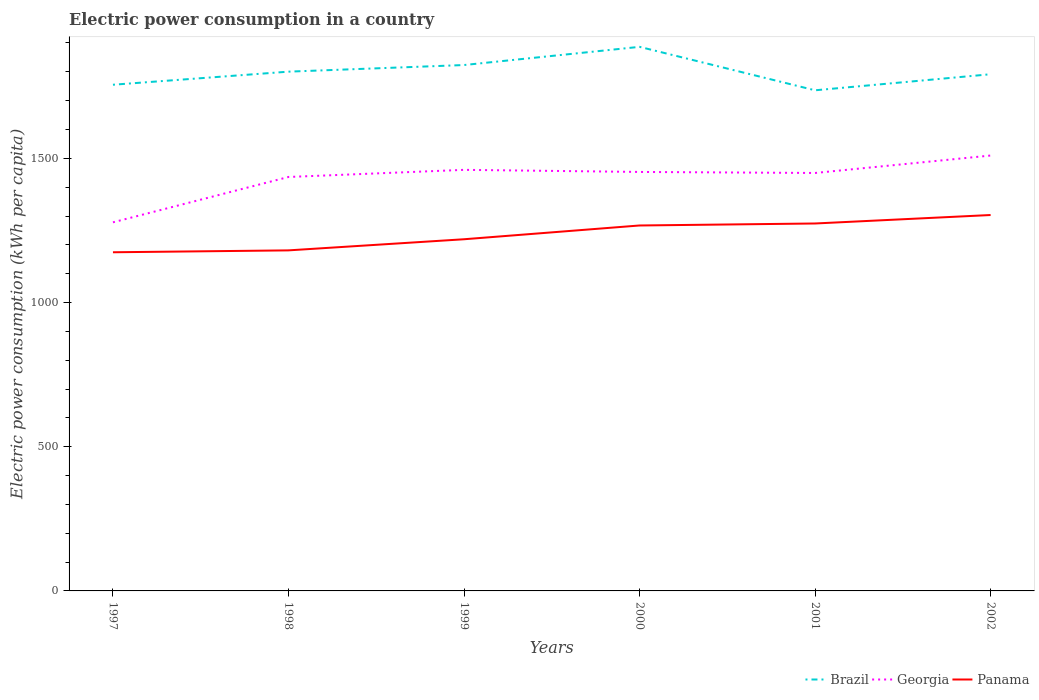How many different coloured lines are there?
Ensure brevity in your answer.  3. Does the line corresponding to Georgia intersect with the line corresponding to Brazil?
Your answer should be compact. No. Across all years, what is the maximum electric power consumption in in Georgia?
Provide a short and direct response. 1278.14. What is the total electric power consumption in in Brazil in the graph?
Give a very brief answer. 19.27. What is the difference between the highest and the second highest electric power consumption in in Georgia?
Provide a short and direct response. 231.62. How many lines are there?
Your response must be concise. 3. How many years are there in the graph?
Offer a terse response. 6. Are the values on the major ticks of Y-axis written in scientific E-notation?
Your response must be concise. No. Does the graph contain any zero values?
Ensure brevity in your answer.  No. Does the graph contain grids?
Ensure brevity in your answer.  No. Where does the legend appear in the graph?
Give a very brief answer. Bottom right. How many legend labels are there?
Offer a terse response. 3. How are the legend labels stacked?
Offer a very short reply. Horizontal. What is the title of the graph?
Ensure brevity in your answer.  Electric power consumption in a country. Does "Switzerland" appear as one of the legend labels in the graph?
Keep it short and to the point. No. What is the label or title of the X-axis?
Ensure brevity in your answer.  Years. What is the label or title of the Y-axis?
Your answer should be compact. Electric power consumption (kWh per capita). What is the Electric power consumption (kWh per capita) of Brazil in 1997?
Keep it short and to the point. 1755.22. What is the Electric power consumption (kWh per capita) of Georgia in 1997?
Your answer should be very brief. 1278.14. What is the Electric power consumption (kWh per capita) of Panama in 1997?
Your answer should be compact. 1174.31. What is the Electric power consumption (kWh per capita) of Brazil in 1998?
Provide a succinct answer. 1800.59. What is the Electric power consumption (kWh per capita) of Georgia in 1998?
Your response must be concise. 1435.38. What is the Electric power consumption (kWh per capita) of Panama in 1998?
Ensure brevity in your answer.  1180.88. What is the Electric power consumption (kWh per capita) of Brazil in 1999?
Offer a very short reply. 1823.55. What is the Electric power consumption (kWh per capita) of Georgia in 1999?
Make the answer very short. 1460.08. What is the Electric power consumption (kWh per capita) of Panama in 1999?
Offer a terse response. 1219.45. What is the Electric power consumption (kWh per capita) of Brazil in 2000?
Offer a terse response. 1886.6. What is the Electric power consumption (kWh per capita) in Georgia in 2000?
Offer a very short reply. 1452.82. What is the Electric power consumption (kWh per capita) in Panama in 2000?
Give a very brief answer. 1267.19. What is the Electric power consumption (kWh per capita) of Brazil in 2001?
Your response must be concise. 1735.95. What is the Electric power consumption (kWh per capita) in Georgia in 2001?
Provide a succinct answer. 1449.25. What is the Electric power consumption (kWh per capita) in Panama in 2001?
Provide a short and direct response. 1274.1. What is the Electric power consumption (kWh per capita) in Brazil in 2002?
Offer a very short reply. 1791.62. What is the Electric power consumption (kWh per capita) of Georgia in 2002?
Provide a succinct answer. 1509.75. What is the Electric power consumption (kWh per capita) of Panama in 2002?
Give a very brief answer. 1303.45. Across all years, what is the maximum Electric power consumption (kWh per capita) of Brazil?
Your answer should be compact. 1886.6. Across all years, what is the maximum Electric power consumption (kWh per capita) of Georgia?
Offer a very short reply. 1509.75. Across all years, what is the maximum Electric power consumption (kWh per capita) in Panama?
Provide a short and direct response. 1303.45. Across all years, what is the minimum Electric power consumption (kWh per capita) in Brazil?
Ensure brevity in your answer.  1735.95. Across all years, what is the minimum Electric power consumption (kWh per capita) in Georgia?
Your answer should be compact. 1278.14. Across all years, what is the minimum Electric power consumption (kWh per capita) of Panama?
Your answer should be very brief. 1174.31. What is the total Electric power consumption (kWh per capita) in Brazil in the graph?
Ensure brevity in your answer.  1.08e+04. What is the total Electric power consumption (kWh per capita) in Georgia in the graph?
Your answer should be compact. 8585.43. What is the total Electric power consumption (kWh per capita) of Panama in the graph?
Your response must be concise. 7419.38. What is the difference between the Electric power consumption (kWh per capita) in Brazil in 1997 and that in 1998?
Offer a terse response. -45.37. What is the difference between the Electric power consumption (kWh per capita) of Georgia in 1997 and that in 1998?
Give a very brief answer. -157.25. What is the difference between the Electric power consumption (kWh per capita) of Panama in 1997 and that in 1998?
Keep it short and to the point. -6.57. What is the difference between the Electric power consumption (kWh per capita) in Brazil in 1997 and that in 1999?
Provide a succinct answer. -68.33. What is the difference between the Electric power consumption (kWh per capita) in Georgia in 1997 and that in 1999?
Give a very brief answer. -181.94. What is the difference between the Electric power consumption (kWh per capita) in Panama in 1997 and that in 1999?
Provide a short and direct response. -45.14. What is the difference between the Electric power consumption (kWh per capita) of Brazil in 1997 and that in 2000?
Make the answer very short. -131.38. What is the difference between the Electric power consumption (kWh per capita) of Georgia in 1997 and that in 2000?
Make the answer very short. -174.69. What is the difference between the Electric power consumption (kWh per capita) of Panama in 1997 and that in 2000?
Your answer should be compact. -92.88. What is the difference between the Electric power consumption (kWh per capita) of Brazil in 1997 and that in 2001?
Make the answer very short. 19.27. What is the difference between the Electric power consumption (kWh per capita) of Georgia in 1997 and that in 2001?
Offer a terse response. -171.12. What is the difference between the Electric power consumption (kWh per capita) in Panama in 1997 and that in 2001?
Offer a terse response. -99.79. What is the difference between the Electric power consumption (kWh per capita) of Brazil in 1997 and that in 2002?
Offer a terse response. -36.4. What is the difference between the Electric power consumption (kWh per capita) in Georgia in 1997 and that in 2002?
Offer a very short reply. -231.62. What is the difference between the Electric power consumption (kWh per capita) in Panama in 1997 and that in 2002?
Offer a terse response. -129.14. What is the difference between the Electric power consumption (kWh per capita) of Brazil in 1998 and that in 1999?
Make the answer very short. -22.96. What is the difference between the Electric power consumption (kWh per capita) of Georgia in 1998 and that in 1999?
Offer a very short reply. -24.69. What is the difference between the Electric power consumption (kWh per capita) of Panama in 1998 and that in 1999?
Offer a terse response. -38.57. What is the difference between the Electric power consumption (kWh per capita) of Brazil in 1998 and that in 2000?
Provide a short and direct response. -86.01. What is the difference between the Electric power consumption (kWh per capita) in Georgia in 1998 and that in 2000?
Keep it short and to the point. -17.44. What is the difference between the Electric power consumption (kWh per capita) in Panama in 1998 and that in 2000?
Offer a very short reply. -86.31. What is the difference between the Electric power consumption (kWh per capita) in Brazil in 1998 and that in 2001?
Offer a very short reply. 64.63. What is the difference between the Electric power consumption (kWh per capita) in Georgia in 1998 and that in 2001?
Offer a very short reply. -13.87. What is the difference between the Electric power consumption (kWh per capita) in Panama in 1998 and that in 2001?
Provide a succinct answer. -93.22. What is the difference between the Electric power consumption (kWh per capita) of Brazil in 1998 and that in 2002?
Your answer should be very brief. 8.97. What is the difference between the Electric power consumption (kWh per capita) in Georgia in 1998 and that in 2002?
Give a very brief answer. -74.37. What is the difference between the Electric power consumption (kWh per capita) of Panama in 1998 and that in 2002?
Give a very brief answer. -122.57. What is the difference between the Electric power consumption (kWh per capita) in Brazil in 1999 and that in 2000?
Ensure brevity in your answer.  -63.05. What is the difference between the Electric power consumption (kWh per capita) in Georgia in 1999 and that in 2000?
Offer a terse response. 7.26. What is the difference between the Electric power consumption (kWh per capita) in Panama in 1999 and that in 2000?
Offer a very short reply. -47.74. What is the difference between the Electric power consumption (kWh per capita) in Brazil in 1999 and that in 2001?
Make the answer very short. 87.59. What is the difference between the Electric power consumption (kWh per capita) of Georgia in 1999 and that in 2001?
Offer a terse response. 10.83. What is the difference between the Electric power consumption (kWh per capita) of Panama in 1999 and that in 2001?
Ensure brevity in your answer.  -54.65. What is the difference between the Electric power consumption (kWh per capita) in Brazil in 1999 and that in 2002?
Your response must be concise. 31.93. What is the difference between the Electric power consumption (kWh per capita) of Georgia in 1999 and that in 2002?
Keep it short and to the point. -49.68. What is the difference between the Electric power consumption (kWh per capita) of Panama in 1999 and that in 2002?
Your answer should be very brief. -84. What is the difference between the Electric power consumption (kWh per capita) in Brazil in 2000 and that in 2001?
Your response must be concise. 150.65. What is the difference between the Electric power consumption (kWh per capita) of Georgia in 2000 and that in 2001?
Your response must be concise. 3.57. What is the difference between the Electric power consumption (kWh per capita) in Panama in 2000 and that in 2001?
Your response must be concise. -6.91. What is the difference between the Electric power consumption (kWh per capita) in Brazil in 2000 and that in 2002?
Your response must be concise. 94.98. What is the difference between the Electric power consumption (kWh per capita) in Georgia in 2000 and that in 2002?
Provide a short and direct response. -56.93. What is the difference between the Electric power consumption (kWh per capita) in Panama in 2000 and that in 2002?
Keep it short and to the point. -36.26. What is the difference between the Electric power consumption (kWh per capita) of Brazil in 2001 and that in 2002?
Make the answer very short. -55.67. What is the difference between the Electric power consumption (kWh per capita) in Georgia in 2001 and that in 2002?
Provide a succinct answer. -60.5. What is the difference between the Electric power consumption (kWh per capita) in Panama in 2001 and that in 2002?
Your answer should be compact. -29.35. What is the difference between the Electric power consumption (kWh per capita) in Brazil in 1997 and the Electric power consumption (kWh per capita) in Georgia in 1998?
Keep it short and to the point. 319.84. What is the difference between the Electric power consumption (kWh per capita) in Brazil in 1997 and the Electric power consumption (kWh per capita) in Panama in 1998?
Your response must be concise. 574.34. What is the difference between the Electric power consumption (kWh per capita) in Georgia in 1997 and the Electric power consumption (kWh per capita) in Panama in 1998?
Give a very brief answer. 97.25. What is the difference between the Electric power consumption (kWh per capita) in Brazil in 1997 and the Electric power consumption (kWh per capita) in Georgia in 1999?
Your answer should be compact. 295.14. What is the difference between the Electric power consumption (kWh per capita) in Brazil in 1997 and the Electric power consumption (kWh per capita) in Panama in 1999?
Ensure brevity in your answer.  535.77. What is the difference between the Electric power consumption (kWh per capita) of Georgia in 1997 and the Electric power consumption (kWh per capita) of Panama in 1999?
Keep it short and to the point. 58.69. What is the difference between the Electric power consumption (kWh per capita) in Brazil in 1997 and the Electric power consumption (kWh per capita) in Georgia in 2000?
Ensure brevity in your answer.  302.4. What is the difference between the Electric power consumption (kWh per capita) in Brazil in 1997 and the Electric power consumption (kWh per capita) in Panama in 2000?
Offer a terse response. 488.03. What is the difference between the Electric power consumption (kWh per capita) in Georgia in 1997 and the Electric power consumption (kWh per capita) in Panama in 2000?
Offer a very short reply. 10.95. What is the difference between the Electric power consumption (kWh per capita) of Brazil in 1997 and the Electric power consumption (kWh per capita) of Georgia in 2001?
Make the answer very short. 305.97. What is the difference between the Electric power consumption (kWh per capita) of Brazil in 1997 and the Electric power consumption (kWh per capita) of Panama in 2001?
Your response must be concise. 481.12. What is the difference between the Electric power consumption (kWh per capita) in Georgia in 1997 and the Electric power consumption (kWh per capita) in Panama in 2001?
Give a very brief answer. 4.04. What is the difference between the Electric power consumption (kWh per capita) of Brazil in 1997 and the Electric power consumption (kWh per capita) of Georgia in 2002?
Offer a terse response. 245.47. What is the difference between the Electric power consumption (kWh per capita) in Brazil in 1997 and the Electric power consumption (kWh per capita) in Panama in 2002?
Provide a short and direct response. 451.77. What is the difference between the Electric power consumption (kWh per capita) in Georgia in 1997 and the Electric power consumption (kWh per capita) in Panama in 2002?
Offer a terse response. -25.32. What is the difference between the Electric power consumption (kWh per capita) of Brazil in 1998 and the Electric power consumption (kWh per capita) of Georgia in 1999?
Make the answer very short. 340.51. What is the difference between the Electric power consumption (kWh per capita) of Brazil in 1998 and the Electric power consumption (kWh per capita) of Panama in 1999?
Give a very brief answer. 581.14. What is the difference between the Electric power consumption (kWh per capita) of Georgia in 1998 and the Electric power consumption (kWh per capita) of Panama in 1999?
Ensure brevity in your answer.  215.93. What is the difference between the Electric power consumption (kWh per capita) in Brazil in 1998 and the Electric power consumption (kWh per capita) in Georgia in 2000?
Offer a very short reply. 347.77. What is the difference between the Electric power consumption (kWh per capita) in Brazil in 1998 and the Electric power consumption (kWh per capita) in Panama in 2000?
Offer a terse response. 533.4. What is the difference between the Electric power consumption (kWh per capita) of Georgia in 1998 and the Electric power consumption (kWh per capita) of Panama in 2000?
Provide a succinct answer. 168.2. What is the difference between the Electric power consumption (kWh per capita) of Brazil in 1998 and the Electric power consumption (kWh per capita) of Georgia in 2001?
Make the answer very short. 351.34. What is the difference between the Electric power consumption (kWh per capita) of Brazil in 1998 and the Electric power consumption (kWh per capita) of Panama in 2001?
Offer a very short reply. 526.49. What is the difference between the Electric power consumption (kWh per capita) of Georgia in 1998 and the Electric power consumption (kWh per capita) of Panama in 2001?
Offer a terse response. 161.29. What is the difference between the Electric power consumption (kWh per capita) of Brazil in 1998 and the Electric power consumption (kWh per capita) of Georgia in 2002?
Your answer should be very brief. 290.83. What is the difference between the Electric power consumption (kWh per capita) of Brazil in 1998 and the Electric power consumption (kWh per capita) of Panama in 2002?
Give a very brief answer. 497.14. What is the difference between the Electric power consumption (kWh per capita) in Georgia in 1998 and the Electric power consumption (kWh per capita) in Panama in 2002?
Your answer should be compact. 131.93. What is the difference between the Electric power consumption (kWh per capita) of Brazil in 1999 and the Electric power consumption (kWh per capita) of Georgia in 2000?
Make the answer very short. 370.73. What is the difference between the Electric power consumption (kWh per capita) in Brazil in 1999 and the Electric power consumption (kWh per capita) in Panama in 2000?
Make the answer very short. 556.36. What is the difference between the Electric power consumption (kWh per capita) in Georgia in 1999 and the Electric power consumption (kWh per capita) in Panama in 2000?
Your answer should be very brief. 192.89. What is the difference between the Electric power consumption (kWh per capita) of Brazil in 1999 and the Electric power consumption (kWh per capita) of Georgia in 2001?
Provide a short and direct response. 374.3. What is the difference between the Electric power consumption (kWh per capita) in Brazil in 1999 and the Electric power consumption (kWh per capita) in Panama in 2001?
Provide a succinct answer. 549.45. What is the difference between the Electric power consumption (kWh per capita) in Georgia in 1999 and the Electric power consumption (kWh per capita) in Panama in 2001?
Keep it short and to the point. 185.98. What is the difference between the Electric power consumption (kWh per capita) of Brazil in 1999 and the Electric power consumption (kWh per capita) of Georgia in 2002?
Your answer should be very brief. 313.79. What is the difference between the Electric power consumption (kWh per capita) in Brazil in 1999 and the Electric power consumption (kWh per capita) in Panama in 2002?
Your answer should be compact. 520.1. What is the difference between the Electric power consumption (kWh per capita) of Georgia in 1999 and the Electric power consumption (kWh per capita) of Panama in 2002?
Offer a very short reply. 156.63. What is the difference between the Electric power consumption (kWh per capita) of Brazil in 2000 and the Electric power consumption (kWh per capita) of Georgia in 2001?
Your answer should be compact. 437.35. What is the difference between the Electric power consumption (kWh per capita) of Brazil in 2000 and the Electric power consumption (kWh per capita) of Panama in 2001?
Keep it short and to the point. 612.5. What is the difference between the Electric power consumption (kWh per capita) in Georgia in 2000 and the Electric power consumption (kWh per capita) in Panama in 2001?
Offer a terse response. 178.72. What is the difference between the Electric power consumption (kWh per capita) of Brazil in 2000 and the Electric power consumption (kWh per capita) of Georgia in 2002?
Provide a succinct answer. 376.85. What is the difference between the Electric power consumption (kWh per capita) of Brazil in 2000 and the Electric power consumption (kWh per capita) of Panama in 2002?
Offer a very short reply. 583.15. What is the difference between the Electric power consumption (kWh per capita) of Georgia in 2000 and the Electric power consumption (kWh per capita) of Panama in 2002?
Make the answer very short. 149.37. What is the difference between the Electric power consumption (kWh per capita) of Brazil in 2001 and the Electric power consumption (kWh per capita) of Georgia in 2002?
Make the answer very short. 226.2. What is the difference between the Electric power consumption (kWh per capita) of Brazil in 2001 and the Electric power consumption (kWh per capita) of Panama in 2002?
Provide a succinct answer. 432.5. What is the difference between the Electric power consumption (kWh per capita) of Georgia in 2001 and the Electric power consumption (kWh per capita) of Panama in 2002?
Your answer should be compact. 145.8. What is the average Electric power consumption (kWh per capita) in Brazil per year?
Provide a succinct answer. 1798.92. What is the average Electric power consumption (kWh per capita) of Georgia per year?
Offer a terse response. 1430.9. What is the average Electric power consumption (kWh per capita) in Panama per year?
Offer a very short reply. 1236.56. In the year 1997, what is the difference between the Electric power consumption (kWh per capita) in Brazil and Electric power consumption (kWh per capita) in Georgia?
Offer a terse response. 477.09. In the year 1997, what is the difference between the Electric power consumption (kWh per capita) of Brazil and Electric power consumption (kWh per capita) of Panama?
Offer a terse response. 580.91. In the year 1997, what is the difference between the Electric power consumption (kWh per capita) of Georgia and Electric power consumption (kWh per capita) of Panama?
Your answer should be very brief. 103.83. In the year 1998, what is the difference between the Electric power consumption (kWh per capita) of Brazil and Electric power consumption (kWh per capita) of Georgia?
Ensure brevity in your answer.  365.2. In the year 1998, what is the difference between the Electric power consumption (kWh per capita) in Brazil and Electric power consumption (kWh per capita) in Panama?
Your answer should be very brief. 619.71. In the year 1998, what is the difference between the Electric power consumption (kWh per capita) of Georgia and Electric power consumption (kWh per capita) of Panama?
Provide a succinct answer. 254.5. In the year 1999, what is the difference between the Electric power consumption (kWh per capita) in Brazil and Electric power consumption (kWh per capita) in Georgia?
Your answer should be compact. 363.47. In the year 1999, what is the difference between the Electric power consumption (kWh per capita) of Brazil and Electric power consumption (kWh per capita) of Panama?
Give a very brief answer. 604.1. In the year 1999, what is the difference between the Electric power consumption (kWh per capita) in Georgia and Electric power consumption (kWh per capita) in Panama?
Give a very brief answer. 240.63. In the year 2000, what is the difference between the Electric power consumption (kWh per capita) in Brazil and Electric power consumption (kWh per capita) in Georgia?
Your answer should be compact. 433.78. In the year 2000, what is the difference between the Electric power consumption (kWh per capita) in Brazil and Electric power consumption (kWh per capita) in Panama?
Offer a terse response. 619.41. In the year 2000, what is the difference between the Electric power consumption (kWh per capita) of Georgia and Electric power consumption (kWh per capita) of Panama?
Provide a succinct answer. 185.63. In the year 2001, what is the difference between the Electric power consumption (kWh per capita) in Brazil and Electric power consumption (kWh per capita) in Georgia?
Offer a very short reply. 286.7. In the year 2001, what is the difference between the Electric power consumption (kWh per capita) in Brazil and Electric power consumption (kWh per capita) in Panama?
Provide a short and direct response. 461.86. In the year 2001, what is the difference between the Electric power consumption (kWh per capita) in Georgia and Electric power consumption (kWh per capita) in Panama?
Keep it short and to the point. 175.15. In the year 2002, what is the difference between the Electric power consumption (kWh per capita) of Brazil and Electric power consumption (kWh per capita) of Georgia?
Your answer should be compact. 281.87. In the year 2002, what is the difference between the Electric power consumption (kWh per capita) in Brazil and Electric power consumption (kWh per capita) in Panama?
Provide a short and direct response. 488.17. In the year 2002, what is the difference between the Electric power consumption (kWh per capita) in Georgia and Electric power consumption (kWh per capita) in Panama?
Make the answer very short. 206.3. What is the ratio of the Electric power consumption (kWh per capita) of Brazil in 1997 to that in 1998?
Your response must be concise. 0.97. What is the ratio of the Electric power consumption (kWh per capita) in Georgia in 1997 to that in 1998?
Offer a terse response. 0.89. What is the ratio of the Electric power consumption (kWh per capita) in Panama in 1997 to that in 1998?
Provide a short and direct response. 0.99. What is the ratio of the Electric power consumption (kWh per capita) of Brazil in 1997 to that in 1999?
Keep it short and to the point. 0.96. What is the ratio of the Electric power consumption (kWh per capita) of Georgia in 1997 to that in 1999?
Give a very brief answer. 0.88. What is the ratio of the Electric power consumption (kWh per capita) of Panama in 1997 to that in 1999?
Your response must be concise. 0.96. What is the ratio of the Electric power consumption (kWh per capita) of Brazil in 1997 to that in 2000?
Ensure brevity in your answer.  0.93. What is the ratio of the Electric power consumption (kWh per capita) in Georgia in 1997 to that in 2000?
Your response must be concise. 0.88. What is the ratio of the Electric power consumption (kWh per capita) of Panama in 1997 to that in 2000?
Your answer should be very brief. 0.93. What is the ratio of the Electric power consumption (kWh per capita) in Brazil in 1997 to that in 2001?
Your answer should be compact. 1.01. What is the ratio of the Electric power consumption (kWh per capita) of Georgia in 1997 to that in 2001?
Your answer should be compact. 0.88. What is the ratio of the Electric power consumption (kWh per capita) in Panama in 1997 to that in 2001?
Ensure brevity in your answer.  0.92. What is the ratio of the Electric power consumption (kWh per capita) of Brazil in 1997 to that in 2002?
Your response must be concise. 0.98. What is the ratio of the Electric power consumption (kWh per capita) of Georgia in 1997 to that in 2002?
Offer a very short reply. 0.85. What is the ratio of the Electric power consumption (kWh per capita) of Panama in 1997 to that in 2002?
Offer a very short reply. 0.9. What is the ratio of the Electric power consumption (kWh per capita) of Brazil in 1998 to that in 1999?
Ensure brevity in your answer.  0.99. What is the ratio of the Electric power consumption (kWh per capita) of Georgia in 1998 to that in 1999?
Keep it short and to the point. 0.98. What is the ratio of the Electric power consumption (kWh per capita) of Panama in 1998 to that in 1999?
Ensure brevity in your answer.  0.97. What is the ratio of the Electric power consumption (kWh per capita) in Brazil in 1998 to that in 2000?
Ensure brevity in your answer.  0.95. What is the ratio of the Electric power consumption (kWh per capita) in Panama in 1998 to that in 2000?
Your response must be concise. 0.93. What is the ratio of the Electric power consumption (kWh per capita) of Brazil in 1998 to that in 2001?
Your answer should be compact. 1.04. What is the ratio of the Electric power consumption (kWh per capita) in Panama in 1998 to that in 2001?
Keep it short and to the point. 0.93. What is the ratio of the Electric power consumption (kWh per capita) in Georgia in 1998 to that in 2002?
Provide a succinct answer. 0.95. What is the ratio of the Electric power consumption (kWh per capita) of Panama in 1998 to that in 2002?
Your answer should be compact. 0.91. What is the ratio of the Electric power consumption (kWh per capita) in Brazil in 1999 to that in 2000?
Your response must be concise. 0.97. What is the ratio of the Electric power consumption (kWh per capita) of Georgia in 1999 to that in 2000?
Provide a short and direct response. 1. What is the ratio of the Electric power consumption (kWh per capita) in Panama in 1999 to that in 2000?
Provide a succinct answer. 0.96. What is the ratio of the Electric power consumption (kWh per capita) of Brazil in 1999 to that in 2001?
Provide a succinct answer. 1.05. What is the ratio of the Electric power consumption (kWh per capita) of Georgia in 1999 to that in 2001?
Ensure brevity in your answer.  1.01. What is the ratio of the Electric power consumption (kWh per capita) in Panama in 1999 to that in 2001?
Offer a terse response. 0.96. What is the ratio of the Electric power consumption (kWh per capita) in Brazil in 1999 to that in 2002?
Your answer should be very brief. 1.02. What is the ratio of the Electric power consumption (kWh per capita) in Georgia in 1999 to that in 2002?
Provide a succinct answer. 0.97. What is the ratio of the Electric power consumption (kWh per capita) of Panama in 1999 to that in 2002?
Provide a succinct answer. 0.94. What is the ratio of the Electric power consumption (kWh per capita) in Brazil in 2000 to that in 2001?
Keep it short and to the point. 1.09. What is the ratio of the Electric power consumption (kWh per capita) of Georgia in 2000 to that in 2001?
Give a very brief answer. 1. What is the ratio of the Electric power consumption (kWh per capita) of Panama in 2000 to that in 2001?
Provide a short and direct response. 0.99. What is the ratio of the Electric power consumption (kWh per capita) of Brazil in 2000 to that in 2002?
Give a very brief answer. 1.05. What is the ratio of the Electric power consumption (kWh per capita) of Georgia in 2000 to that in 2002?
Keep it short and to the point. 0.96. What is the ratio of the Electric power consumption (kWh per capita) of Panama in 2000 to that in 2002?
Keep it short and to the point. 0.97. What is the ratio of the Electric power consumption (kWh per capita) in Brazil in 2001 to that in 2002?
Make the answer very short. 0.97. What is the ratio of the Electric power consumption (kWh per capita) of Georgia in 2001 to that in 2002?
Give a very brief answer. 0.96. What is the ratio of the Electric power consumption (kWh per capita) in Panama in 2001 to that in 2002?
Provide a short and direct response. 0.98. What is the difference between the highest and the second highest Electric power consumption (kWh per capita) of Brazil?
Give a very brief answer. 63.05. What is the difference between the highest and the second highest Electric power consumption (kWh per capita) of Georgia?
Your answer should be very brief. 49.68. What is the difference between the highest and the second highest Electric power consumption (kWh per capita) in Panama?
Your answer should be very brief. 29.35. What is the difference between the highest and the lowest Electric power consumption (kWh per capita) of Brazil?
Offer a terse response. 150.65. What is the difference between the highest and the lowest Electric power consumption (kWh per capita) of Georgia?
Provide a short and direct response. 231.62. What is the difference between the highest and the lowest Electric power consumption (kWh per capita) in Panama?
Provide a succinct answer. 129.14. 